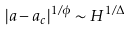Convert formula to latex. <formula><loc_0><loc_0><loc_500><loc_500>| a - a _ { c } | ^ { 1 / \phi } \sim H ^ { 1 / \Delta }</formula> 